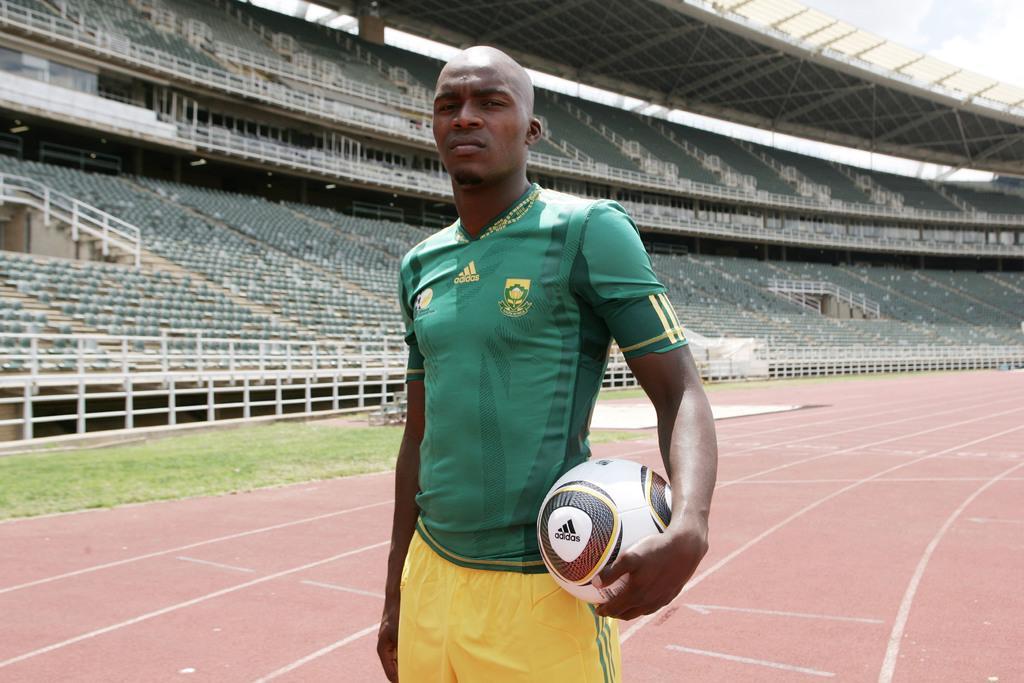Describe this image in one or two sentences. In this image I can see a man in football jersey. I can also see a football in his hand. In the background I can see a stadium. 